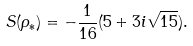Convert formula to latex. <formula><loc_0><loc_0><loc_500><loc_500>S ( \rho _ { \ast } ) = - \frac { 1 } { 1 6 } ( 5 + 3 i \sqrt { 1 5 } ) .</formula> 